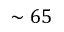Convert formula to latex. <formula><loc_0><loc_0><loc_500><loc_500>\sim 6 5</formula> 